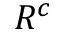<formula> <loc_0><loc_0><loc_500><loc_500>R ^ { c }</formula> 